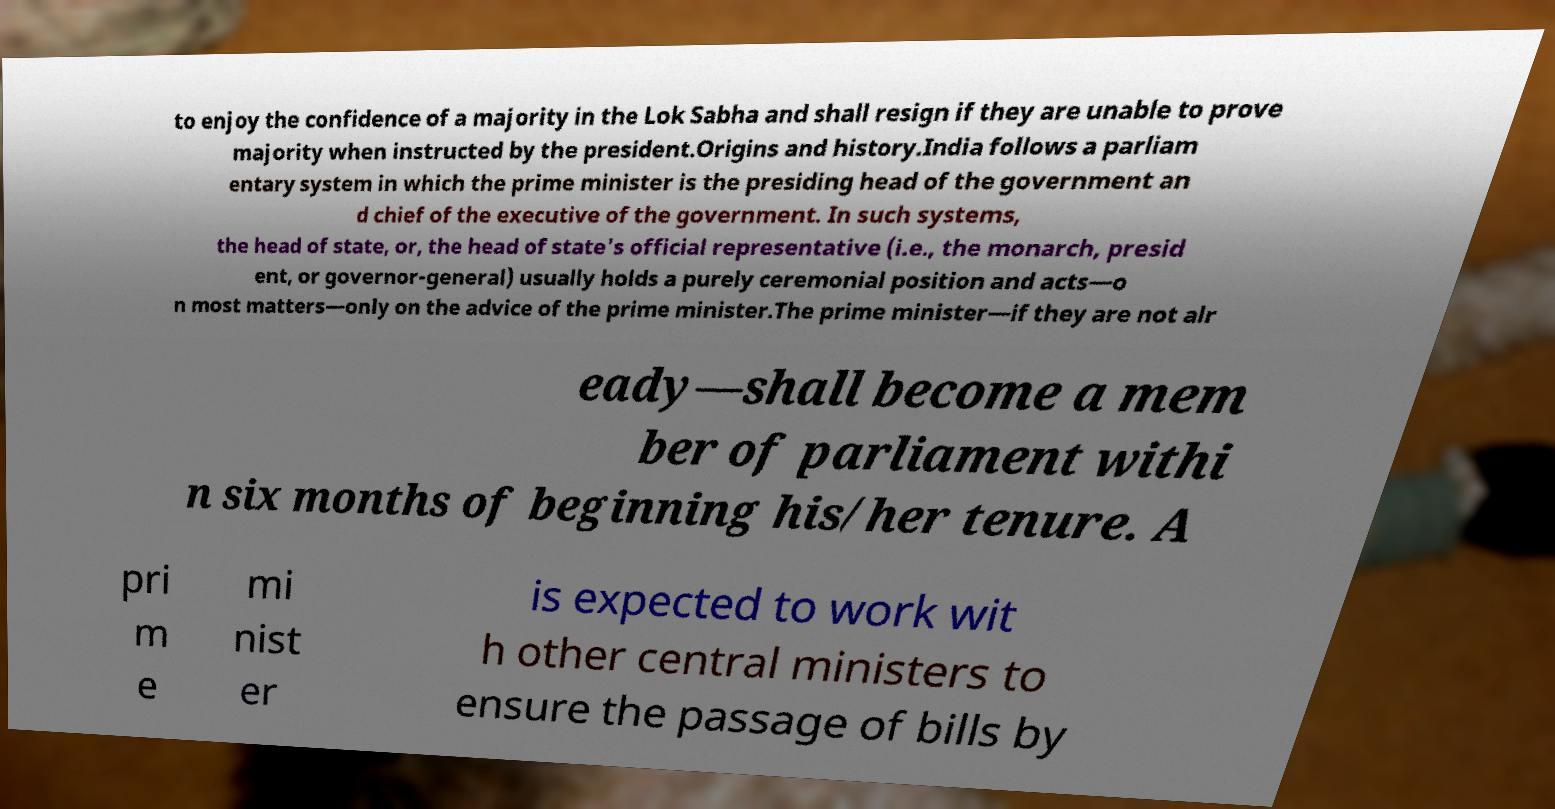I need the written content from this picture converted into text. Can you do that? to enjoy the confidence of a majority in the Lok Sabha and shall resign if they are unable to prove majority when instructed by the president.Origins and history.India follows a parliam entary system in which the prime minister is the presiding head of the government an d chief of the executive of the government. In such systems, the head of state, or, the head of state's official representative (i.e., the monarch, presid ent, or governor-general) usually holds a purely ceremonial position and acts—o n most matters—only on the advice of the prime minister.The prime minister—if they are not alr eady—shall become a mem ber of parliament withi n six months of beginning his/her tenure. A pri m e mi nist er is expected to work wit h other central ministers to ensure the passage of bills by 